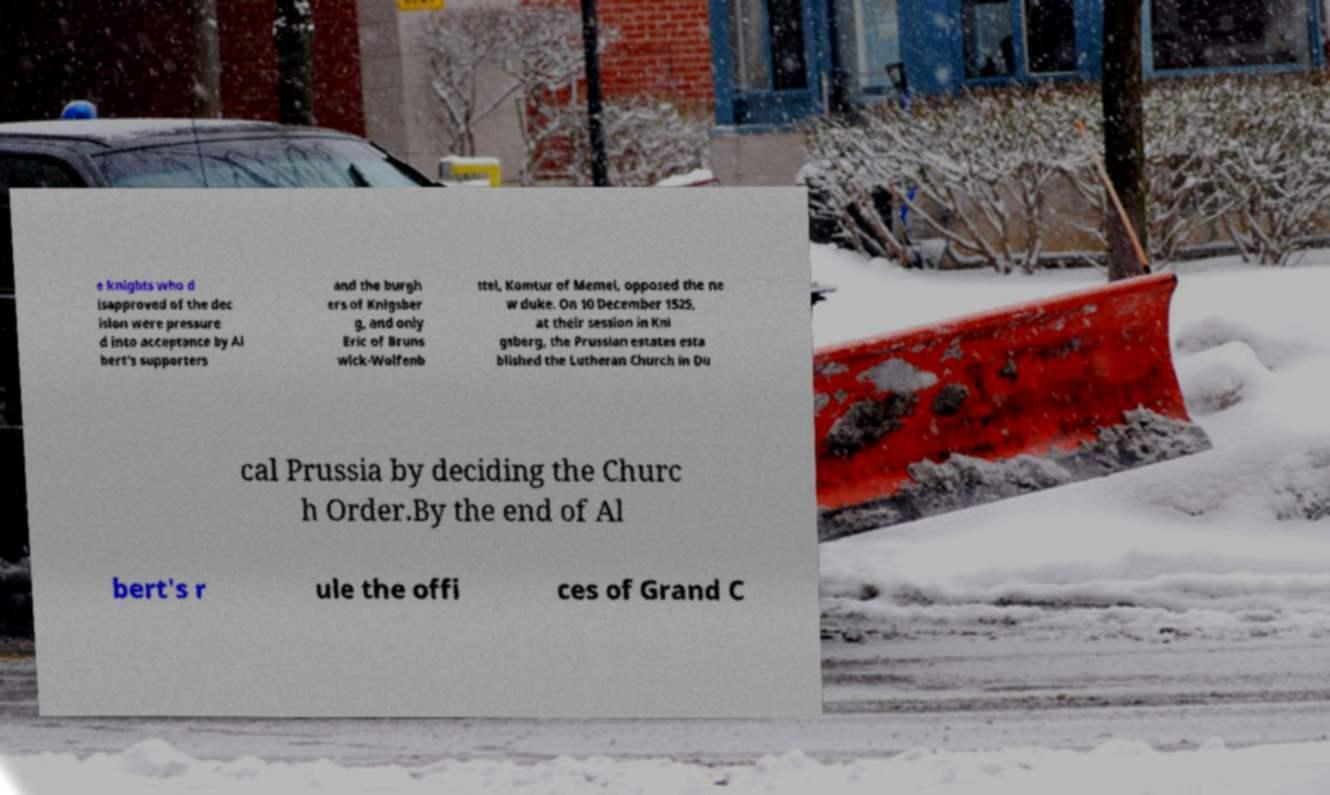What messages or text are displayed in this image? I need them in a readable, typed format. e knights who d isapproved of the dec ision were pressure d into acceptance by Al bert's supporters and the burgh ers of Knigsber g, and only Eric of Bruns wick-Wolfenb ttel, Komtur of Memel, opposed the ne w duke. On 10 December 1525, at their session in Kni gsberg, the Prussian estates esta blished the Lutheran Church in Du cal Prussia by deciding the Churc h Order.By the end of Al bert's r ule the offi ces of Grand C 